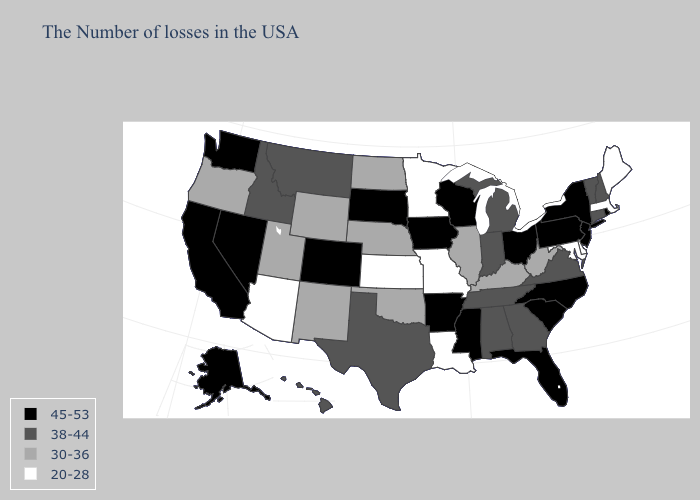Does Oregon have the same value as Wyoming?
Answer briefly. Yes. Does the map have missing data?
Write a very short answer. No. Does Minnesota have the same value as Nevada?
Give a very brief answer. No. Does California have the highest value in the West?
Be succinct. Yes. What is the lowest value in the USA?
Give a very brief answer. 20-28. How many symbols are there in the legend?
Write a very short answer. 4. What is the lowest value in the USA?
Answer briefly. 20-28. Among the states that border Iowa , which have the lowest value?
Write a very short answer. Missouri, Minnesota. Does the first symbol in the legend represent the smallest category?
Give a very brief answer. No. What is the highest value in the USA?
Give a very brief answer. 45-53. What is the value of Maryland?
Be succinct. 20-28. Name the states that have a value in the range 30-36?
Answer briefly. West Virginia, Kentucky, Illinois, Nebraska, Oklahoma, North Dakota, Wyoming, New Mexico, Utah, Oregon. Is the legend a continuous bar?
Write a very short answer. No. Name the states that have a value in the range 30-36?
Concise answer only. West Virginia, Kentucky, Illinois, Nebraska, Oklahoma, North Dakota, Wyoming, New Mexico, Utah, Oregon. Does Vermont have the same value as Washington?
Give a very brief answer. No. 